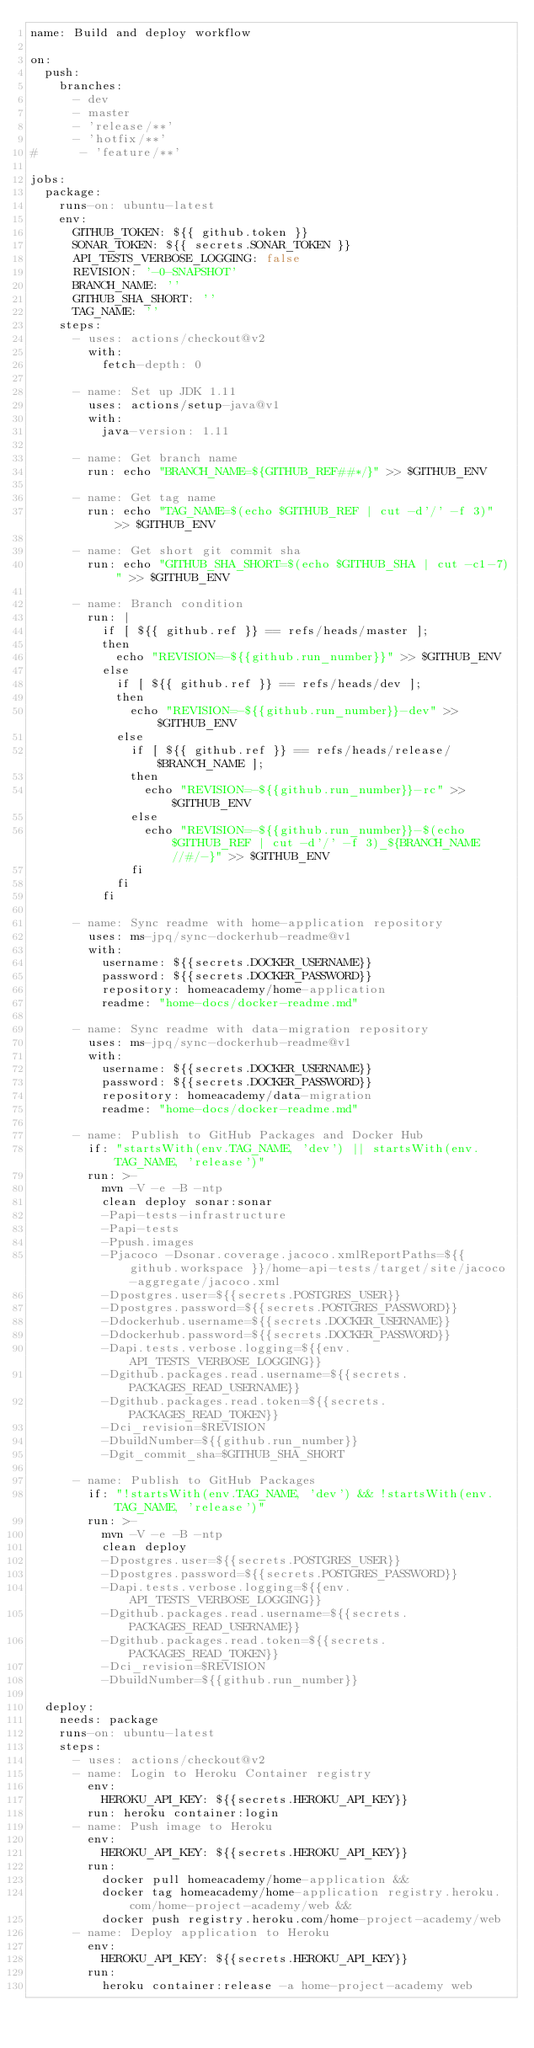Convert code to text. <code><loc_0><loc_0><loc_500><loc_500><_YAML_>name: Build and deploy workflow

on:
  push:
    branches:
      - dev
      - master
      - 'release/**'
      - 'hotfix/**'
#      - 'feature/**'

jobs:
  package:
    runs-on: ubuntu-latest
    env:
      GITHUB_TOKEN: ${{ github.token }}
      SONAR_TOKEN: ${{ secrets.SONAR_TOKEN }}
      API_TESTS_VERBOSE_LOGGING: false
      REVISION: '-0-SNAPSHOT'
      BRANCH_NAME: ''
      GITHUB_SHA_SHORT: ''
      TAG_NAME: ''
    steps:
      - uses: actions/checkout@v2
        with:
          fetch-depth: 0

      - name: Set up JDK 1.11
        uses: actions/setup-java@v1
        with:
          java-version: 1.11

      - name: Get branch name
        run: echo "BRANCH_NAME=${GITHUB_REF##*/}" >> $GITHUB_ENV

      - name: Get tag name
        run: echo "TAG_NAME=$(echo $GITHUB_REF | cut -d'/' -f 3)" >> $GITHUB_ENV

      - name: Get short git commit sha
        run: echo "GITHUB_SHA_SHORT=$(echo $GITHUB_SHA | cut -c1-7)" >> $GITHUB_ENV

      - name: Branch condition
        run: |
          if [ ${{ github.ref }} == refs/heads/master ];
          then
            echo "REVISION=-${{github.run_number}}" >> $GITHUB_ENV
          else
            if [ ${{ github.ref }} == refs/heads/dev ];
            then
              echo "REVISION=-${{github.run_number}}-dev" >> $GITHUB_ENV
            else
              if [ ${{ github.ref }} == refs/heads/release/$BRANCH_NAME ];
              then
                echo "REVISION=-${{github.run_number}}-rc" >> $GITHUB_ENV
              else
                echo "REVISION=-${{github.run_number}}-$(echo $GITHUB_REF | cut -d'/' -f 3)_${BRANCH_NAME//#/-}" >> $GITHUB_ENV
              fi
            fi
          fi

      - name: Sync readme with home-application repository
        uses: ms-jpq/sync-dockerhub-readme@v1
        with:
          username: ${{secrets.DOCKER_USERNAME}}
          password: ${{secrets.DOCKER_PASSWORD}}
          repository: homeacademy/home-application
          readme: "home-docs/docker-readme.md"

      - name: Sync readme with data-migration repository
        uses: ms-jpq/sync-dockerhub-readme@v1
        with:
          username: ${{secrets.DOCKER_USERNAME}}
          password: ${{secrets.DOCKER_PASSWORD}}
          repository: homeacademy/data-migration
          readme: "home-docs/docker-readme.md"

      - name: Publish to GitHub Packages and Docker Hub
        if: "startsWith(env.TAG_NAME, 'dev') || startsWith(env.TAG_NAME, 'release')"
        run: >-
          mvn -V -e -B -ntp
          clean deploy sonar:sonar
          -Papi-tests-infrastructure
          -Papi-tests
          -Ppush.images
          -Pjacoco -Dsonar.coverage.jacoco.xmlReportPaths=${{ github.workspace }}/home-api-tests/target/site/jacoco-aggregate/jacoco.xml
          -Dpostgres.user=${{secrets.POSTGRES_USER}}
          -Dpostgres.password=${{secrets.POSTGRES_PASSWORD}}
          -Ddockerhub.username=${{secrets.DOCKER_USERNAME}}
          -Ddockerhub.password=${{secrets.DOCKER_PASSWORD}}
          -Dapi.tests.verbose.logging=${{env.API_TESTS_VERBOSE_LOGGING}}
          -Dgithub.packages.read.username=${{secrets.PACKAGES_READ_USERNAME}}
          -Dgithub.packages.read.token=${{secrets.PACKAGES_READ_TOKEN}}
          -Dci_revision=$REVISION
          -DbuildNumber=${{github.run_number}}
          -Dgit_commit_sha=$GITHUB_SHA_SHORT

      - name: Publish to GitHub Packages
        if: "!startsWith(env.TAG_NAME, 'dev') && !startsWith(env.TAG_NAME, 'release')"
        run: >-
          mvn -V -e -B -ntp
          clean deploy
          -Dpostgres.user=${{secrets.POSTGRES_USER}}
          -Dpostgres.password=${{secrets.POSTGRES_PASSWORD}}
          -Dapi.tests.verbose.logging=${{env.API_TESTS_VERBOSE_LOGGING}}
          -Dgithub.packages.read.username=${{secrets.PACKAGES_READ_USERNAME}}
          -Dgithub.packages.read.token=${{secrets.PACKAGES_READ_TOKEN}}
          -Dci_revision=$REVISION
          -DbuildNumber=${{github.run_number}}

  deploy:
    needs: package
    runs-on: ubuntu-latest
    steps:
      - uses: actions/checkout@v2
      - name: Login to Heroku Container registry
        env:
          HEROKU_API_KEY: ${{secrets.HEROKU_API_KEY}}
        run: heroku container:login
      - name: Push image to Heroku
        env:
          HEROKU_API_KEY: ${{secrets.HEROKU_API_KEY}}
        run:
          docker pull homeacademy/home-application &&
          docker tag homeacademy/home-application registry.heroku.com/home-project-academy/web &&
          docker push registry.heroku.com/home-project-academy/web
      - name: Deploy application to Heroku
        env:
          HEROKU_API_KEY: ${{secrets.HEROKU_API_KEY}}
        run:
          heroku container:release -a home-project-academy web
</code> 